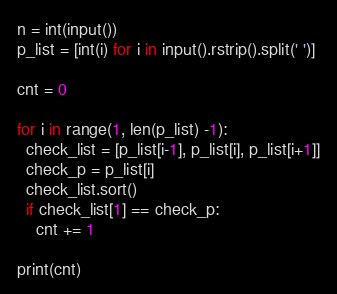<code> <loc_0><loc_0><loc_500><loc_500><_Python_>n = int(input())
p_list = [int(i) for i in input().rstrip().split(' ')]

cnt = 0

for i in range(1, len(p_list) -1):
  check_list = [p_list[i-1], p_list[i], p_list[i+1]]
  check_p = p_list[i]
  check_list.sort()
  if check_list[1] == check_p:
    cnt += 1

print(cnt)</code> 